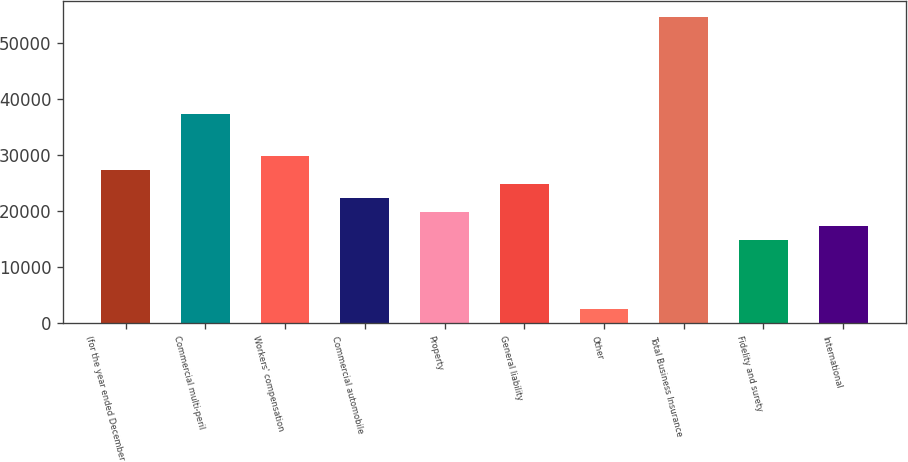Convert chart. <chart><loc_0><loc_0><loc_500><loc_500><bar_chart><fcel>(for the year ended December<fcel>Commercial multi-peril<fcel>Workers' compensation<fcel>Commercial automobile<fcel>Property<fcel>General liability<fcel>Other<fcel>Total Business Insurance<fcel>Fidelity and surety<fcel>International<nl><fcel>27378.8<fcel>37334<fcel>29867.6<fcel>22401.2<fcel>19912.4<fcel>24890<fcel>2490.8<fcel>54755.6<fcel>14934.8<fcel>17423.6<nl></chart> 